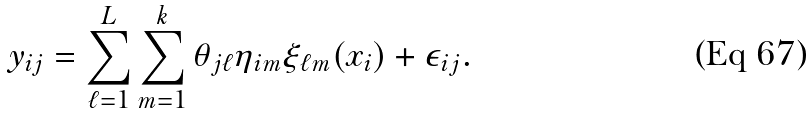<formula> <loc_0><loc_0><loc_500><loc_500>y _ { i j } = \sum _ { \ell = 1 } ^ { L } \sum _ { m = 1 } ^ { k } \theta _ { j \ell } \eta _ { i m } \xi _ { \ell m } ( x _ { i } ) + \epsilon _ { i j } .</formula> 